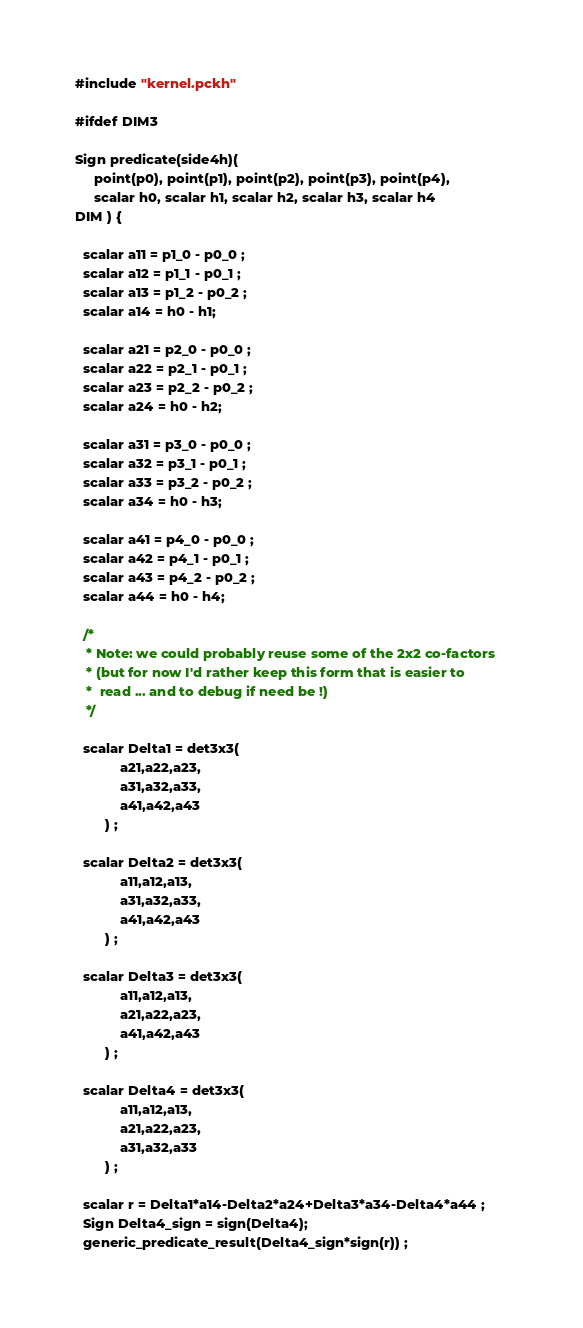<code> <loc_0><loc_0><loc_500><loc_500><_SQL_>#include "kernel.pckh"

#ifdef DIM3

Sign predicate(side4h)(
     point(p0), point(p1), point(p2), point(p3), point(p4), 
     scalar h0, scalar h1, scalar h2, scalar h3, scalar h4 
DIM ) {

  scalar a11 = p1_0 - p0_0 ;
  scalar a12 = p1_1 - p0_1 ;
  scalar a13 = p1_2 - p0_2 ;
  scalar a14 = h0 - h1;

  scalar a21 = p2_0 - p0_0 ;
  scalar a22 = p2_1 - p0_1 ;
  scalar a23 = p2_2 - p0_2 ;
  scalar a24 = h0 - h2;

  scalar a31 = p3_0 - p0_0 ;
  scalar a32 = p3_1 - p0_1 ;
  scalar a33 = p3_2 - p0_2 ;
  scalar a34 = h0 - h3;

  scalar a41 = p4_0 - p0_0 ;
  scalar a42 = p4_1 - p0_1 ;
  scalar a43 = p4_2 - p0_2 ;
  scalar a44 = h0 - h4;

  /*
   * Note: we could probably reuse some of the 2x2 co-factors 
   * (but for now I'd rather keep this form that is easier to
   *  read ... and to debug if need be !)
   */

  scalar Delta1 = det3x3(
            a21,a22,a23,
            a31,a32,a33,
            a41,a42,a43
        ) ;
  
  scalar Delta2 = det3x3(
            a11,a12,a13,
            a31,a32,a33,
            a41,a42,a43
        ) ;
 
  scalar Delta3 = det3x3(
            a11,a12,a13,
            a21,a22,a23,
            a41,a42,a43
        ) ;
 
  scalar Delta4 = det3x3(
            a11,a12,a13,
            a21,a22,a23,
            a31,a32,a33
        ) ;
 
  scalar r = Delta1*a14-Delta2*a24+Delta3*a34-Delta4*a44 ;      
  Sign Delta4_sign = sign(Delta4);
  generic_predicate_result(Delta4_sign*sign(r)) ;</code> 